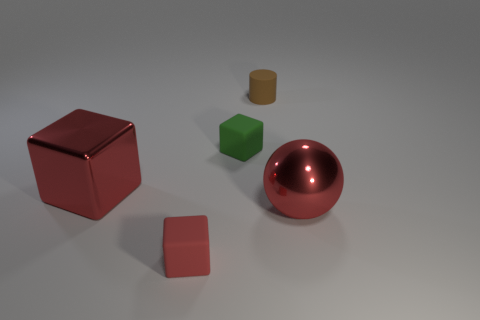Add 2 big red shiny things. How many objects exist? 7 Subtract all cylinders. How many objects are left? 4 Add 3 big gray matte balls. How many big gray matte balls exist? 3 Subtract 0 gray cubes. How many objects are left? 5 Subtract all small metallic cubes. Subtract all large red spheres. How many objects are left? 4 Add 2 big balls. How many big balls are left? 3 